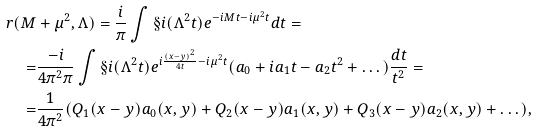<formula> <loc_0><loc_0><loc_500><loc_500>r ( M & + \mu ^ { 2 } , \Lambda ) = \frac { i } { \pi } \int \S i ( \Lambda ^ { 2 } t ) e ^ { - i M t - i \mu ^ { 2 } t } d t = \\ = & \frac { - i } { 4 \pi ^ { 2 } \pi } \int \S i ( \Lambda ^ { 2 } t ) e ^ { i \frac { ( x - y ) ^ { 2 } } { 4 t } - i \mu ^ { 2 } t } ( a _ { 0 } + i a _ { 1 } t - a _ { 2 } t ^ { 2 } + \dots ) \frac { d t } { t ^ { 2 } } = \\ = & \frac { 1 } { 4 \pi ^ { 2 } } ( Q _ { 1 } ( x - y ) a _ { 0 } ( x , y ) + Q _ { 2 } ( x - y ) a _ { 1 } ( x , y ) + Q _ { 3 } ( x - y ) a _ { 2 } ( x , y ) + \dots ) ,</formula> 